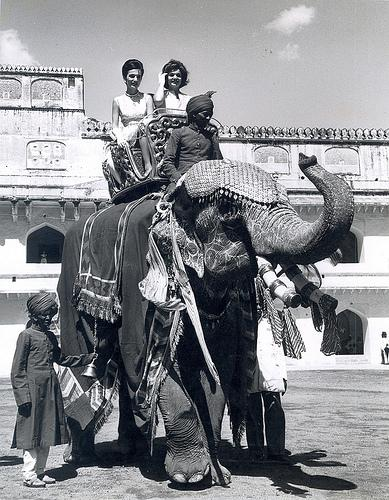Question: when was this photo taken?
Choices:
A. In the morning.
B. During daylight.
C. At night.
D. At dusk.
Answer with the letter. Answer: B Question: what tone is the picture?
Choices:
A. Sepia.
B. Color.
C. Antique.
D. Black and White.
Answer with the letter. Answer: D Question: what animal do you see?
Choices:
A. Elephant.
B. Giraffe.
C. Cheetah.
D. Zebra.
Answer with the letter. Answer: A Question: how many elephants do you see?
Choices:
A. 2.
B. 1.
C. 3.
D. 4.
Answer with the letter. Answer: B Question: where is the building?
Choices:
A. In front of the elephant.
B. Beside the elephant.
C. Behind the elephant.
D. Across from the elephant.
Answer with the letter. Answer: C Question: what are the people on top the elephant doing?
Choices:
A. Performing.
B. Racing.
C. Going for a ride.
D. Training the elephant.
Answer with the letter. Answer: C 